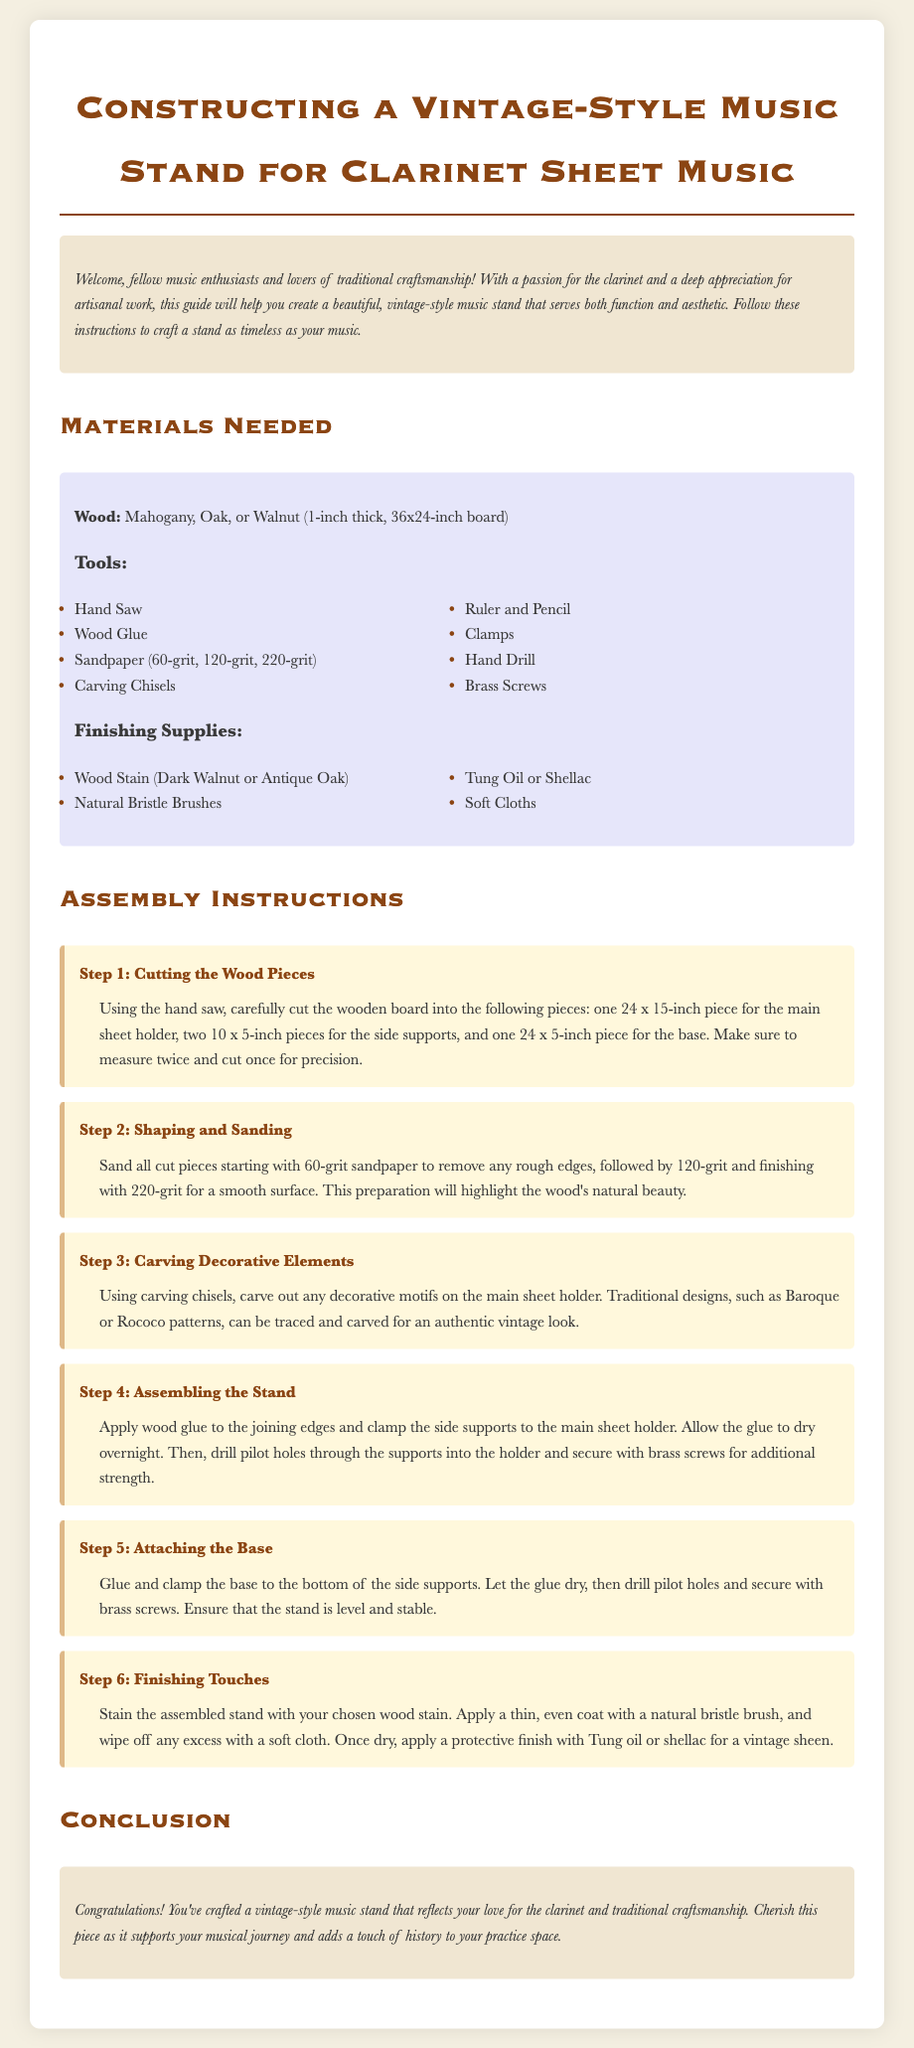What wood types are suggested? The document mentions three types of wood that can be used for the music stand, specifically Mahogany, Oak, or Walnut.
Answer: Mahogany, Oak, Walnut How thick should the wood board be? The instructions specify that the wooden board should be 1 inch thick for constructing the stand.
Answer: 1 inch What is the size of the main sheet holder piece? The document states that the main sheet holder piece should be cut to a size of 24 x 15 inches.
Answer: 24 x 15 inches What grit sandpaper should be used first? The assembly instructions indicate that 60-grit sandpaper should be used first to remove rough edges.
Answer: 60-grit How many decorative motifs can be carved? The document allows for any number of decorative motifs as long as they are traditional designs, such as Baroque or Rococo. The interpretation here is open to creativity.
Answer: N/A (open to creativity) What is the purpose of using brass screws? The document states that brass screws provide additional strength in securing the components of the music stand together.
Answer: Additional strength How long should the glue dry when assembling? The instructions mention that the glue should be allowed to dry overnight during the assembly.
Answer: Overnight What protective finish can be applied after staining? The finishing supplies include Tung Oil or Shellac as options for a protective finish.
Answer: Tung Oil or Shellac 